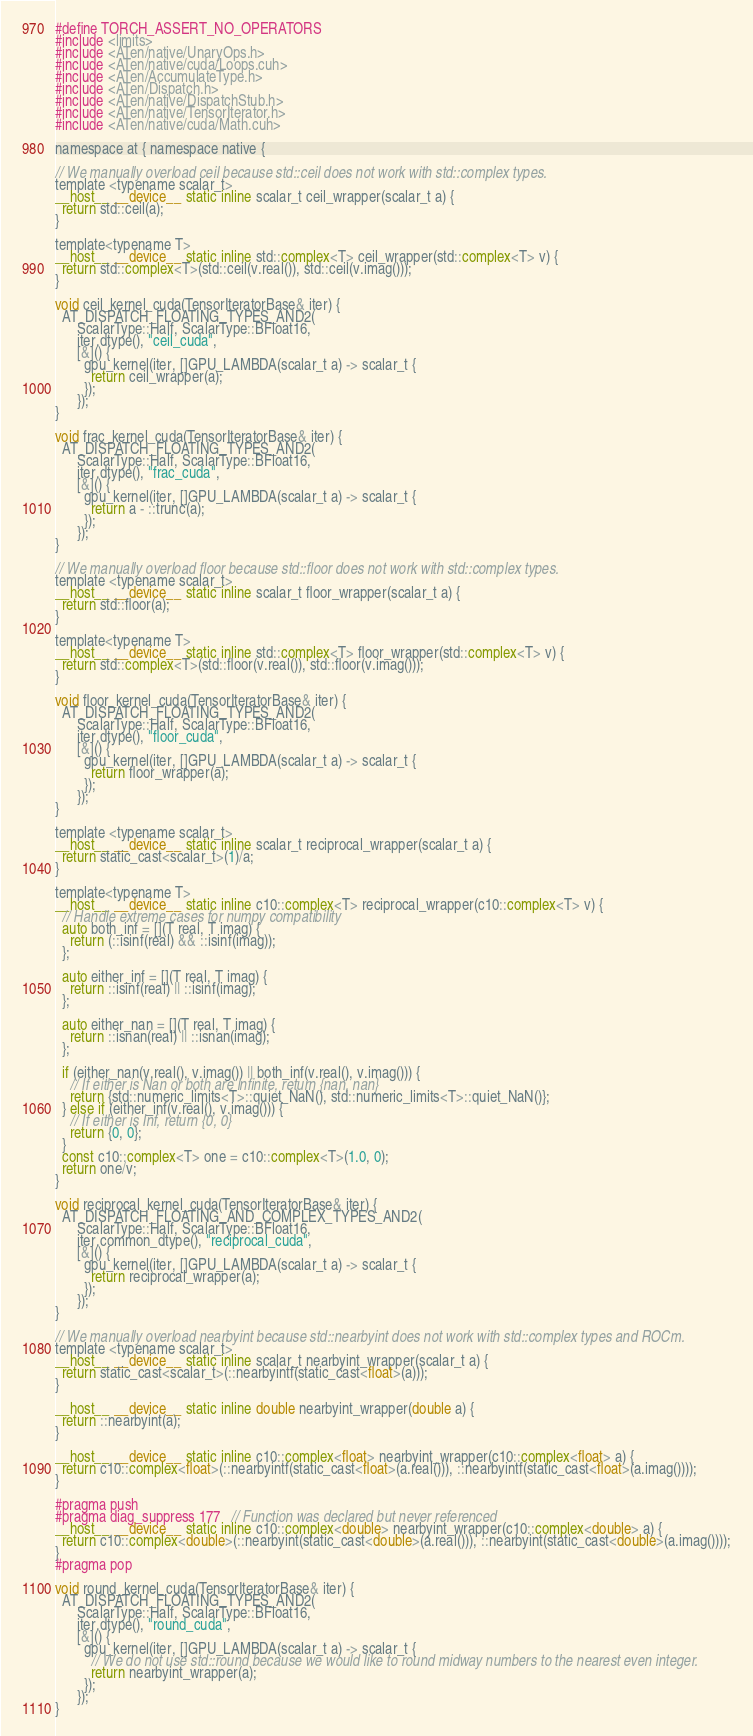<code> <loc_0><loc_0><loc_500><loc_500><_Cuda_>#define TORCH_ASSERT_NO_OPERATORS
#include <limits>
#include <ATen/native/UnaryOps.h>
#include <ATen/native/cuda/Loops.cuh>
#include <ATen/AccumulateType.h>
#include <ATen/Dispatch.h>
#include <ATen/native/DispatchStub.h>
#include <ATen/native/TensorIterator.h>
#include <ATen/native/cuda/Math.cuh>

namespace at { namespace native {

// We manually overload ceil because std::ceil does not work with std::complex types.
template <typename scalar_t>
__host__ __device__ static inline scalar_t ceil_wrapper(scalar_t a) {
  return std::ceil(a);
}

template<typename T>
__host__ __device__ static inline std::complex<T> ceil_wrapper(std::complex<T> v) {
  return std::complex<T>(std::ceil(v.real()), std::ceil(v.imag()));
}

void ceil_kernel_cuda(TensorIteratorBase& iter) {
  AT_DISPATCH_FLOATING_TYPES_AND2(
      ScalarType::Half, ScalarType::BFloat16,
      iter.dtype(), "ceil_cuda",
      [&]() {
        gpu_kernel(iter, []GPU_LAMBDA(scalar_t a) -> scalar_t {
          return ceil_wrapper(a);
        });
      });
}

void frac_kernel_cuda(TensorIteratorBase& iter) {
  AT_DISPATCH_FLOATING_TYPES_AND2(
      ScalarType::Half, ScalarType::BFloat16,
      iter.dtype(), "frac_cuda",
      [&]() {
        gpu_kernel(iter, []GPU_LAMBDA(scalar_t a) -> scalar_t {
          return a - ::trunc(a);
        });
      });
}

// We manually overload floor because std::floor does not work with std::complex types.
template <typename scalar_t>
__host__ __device__ static inline scalar_t floor_wrapper(scalar_t a) {
  return std::floor(a);
}

template<typename T>
__host__ __device__ static inline std::complex<T> floor_wrapper(std::complex<T> v) {
  return std::complex<T>(std::floor(v.real()), std::floor(v.imag()));
}

void floor_kernel_cuda(TensorIteratorBase& iter) {
  AT_DISPATCH_FLOATING_TYPES_AND2(
      ScalarType::Half, ScalarType::BFloat16,
      iter.dtype(), "floor_cuda",
      [&]() {
        gpu_kernel(iter, []GPU_LAMBDA(scalar_t a) -> scalar_t {
          return floor_wrapper(a);
        });
      });
}

template <typename scalar_t>
__host__ __device__ static inline scalar_t reciprocal_wrapper(scalar_t a) {
  return static_cast<scalar_t>(1)/a;
}

template<typename T>
__host__ __device__ static inline c10::complex<T> reciprocal_wrapper(c10::complex<T> v) {
  // Handle extreme cases for numpy compatibility
  auto both_inf = [](T real, T imag) {
    return (::isinf(real) && ::isinf(imag));
  };

  auto either_inf = [](T real, T imag) {
    return ::isinf(real) || ::isinf(imag);
  };

  auto either_nan = [](T real, T imag) {
    return ::isnan(real) || ::isnan(imag);
  };

  if (either_nan(v.real(), v.imag()) || both_inf(v.real(), v.imag())) {
    // If either is Nan or both are infinite, return {nan, nan}
    return {std::numeric_limits<T>::quiet_NaN(), std::numeric_limits<T>::quiet_NaN()};
  } else if (either_inf(v.real(), v.imag())) {
    // If either is Inf, return {0, 0}
    return {0, 0};
  }
  const c10::complex<T> one = c10::complex<T>(1.0, 0);
  return one/v;
}

void reciprocal_kernel_cuda(TensorIteratorBase& iter) {
  AT_DISPATCH_FLOATING_AND_COMPLEX_TYPES_AND2(
      ScalarType::Half, ScalarType::BFloat16,
      iter.common_dtype(), "reciprocal_cuda",
      [&]() {
        gpu_kernel(iter, []GPU_LAMBDA(scalar_t a) -> scalar_t {
          return reciprocal_wrapper(a);
        });
      });
}

// We manually overload nearbyint because std::nearbyint does not work with std::complex types and ROCm.
template <typename scalar_t>
__host__ __device__ static inline scalar_t nearbyint_wrapper(scalar_t a) {
  return static_cast<scalar_t>(::nearbyintf(static_cast<float>(a)));
}

__host__ __device__ static inline double nearbyint_wrapper(double a) {
  return ::nearbyint(a);
}

__host__ __device__ static inline c10::complex<float> nearbyint_wrapper(c10::complex<float> a) {
  return c10::complex<float>(::nearbyintf(static_cast<float>(a.real())), ::nearbyintf(static_cast<float>(a.imag())));
}

#pragma push
#pragma diag_suppress 177   // Function was declared but never referenced
__host__ __device__ static inline c10::complex<double> nearbyint_wrapper(c10::complex<double> a) {
  return c10::complex<double>(::nearbyint(static_cast<double>(a.real())), ::nearbyint(static_cast<double>(a.imag())));
}
#pragma pop

void round_kernel_cuda(TensorIteratorBase& iter) {
  AT_DISPATCH_FLOATING_TYPES_AND2(
      ScalarType::Half, ScalarType::BFloat16,
      iter.dtype(), "round_cuda",
      [&]() {
        gpu_kernel(iter, []GPU_LAMBDA(scalar_t a) -> scalar_t {
          // We do not use std::round because we would like to round midway numbers to the nearest even integer.
          return nearbyint_wrapper(a);
        });
      });
}
</code> 